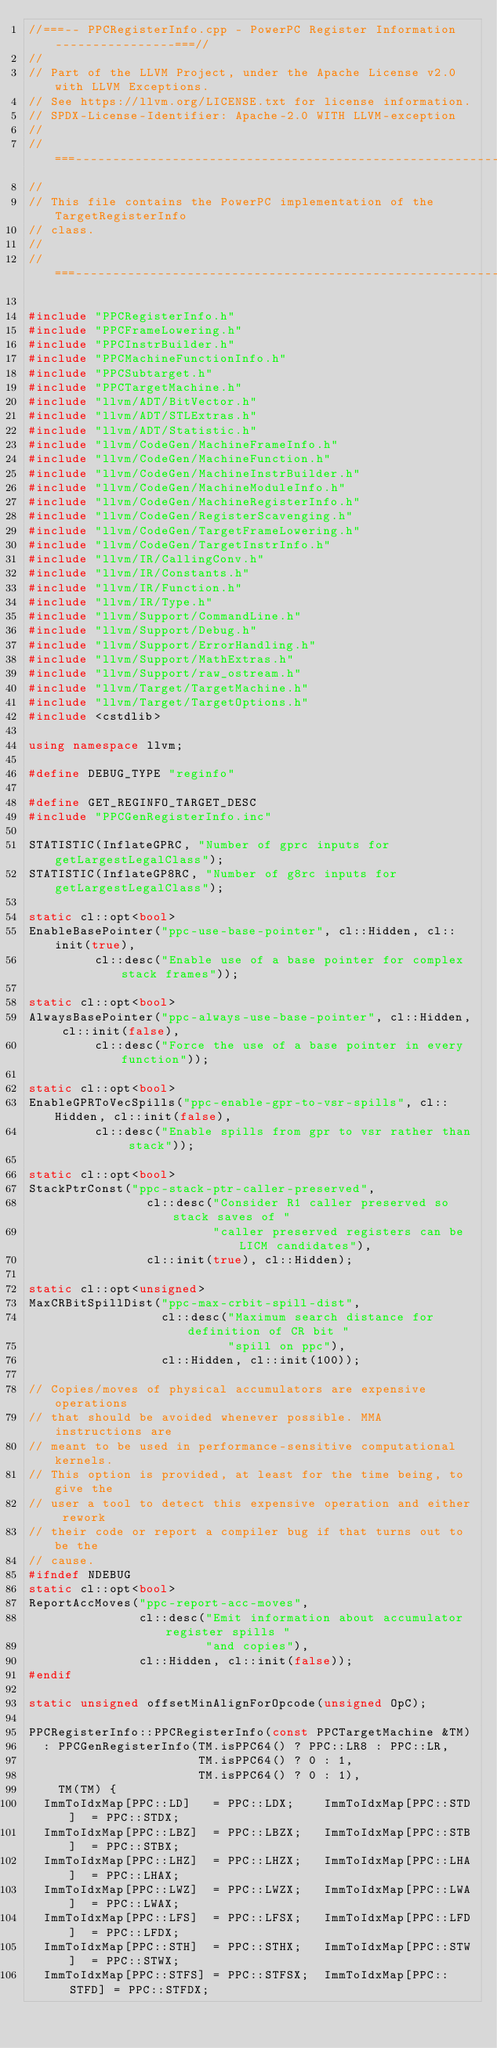<code> <loc_0><loc_0><loc_500><loc_500><_C++_>//===-- PPCRegisterInfo.cpp - PowerPC Register Information ----------------===//
//
// Part of the LLVM Project, under the Apache License v2.0 with LLVM Exceptions.
// See https://llvm.org/LICENSE.txt for license information.
// SPDX-License-Identifier: Apache-2.0 WITH LLVM-exception
//
//===----------------------------------------------------------------------===//
//
// This file contains the PowerPC implementation of the TargetRegisterInfo
// class.
//
//===----------------------------------------------------------------------===//

#include "PPCRegisterInfo.h"
#include "PPCFrameLowering.h"
#include "PPCInstrBuilder.h"
#include "PPCMachineFunctionInfo.h"
#include "PPCSubtarget.h"
#include "PPCTargetMachine.h"
#include "llvm/ADT/BitVector.h"
#include "llvm/ADT/STLExtras.h"
#include "llvm/ADT/Statistic.h"
#include "llvm/CodeGen/MachineFrameInfo.h"
#include "llvm/CodeGen/MachineFunction.h"
#include "llvm/CodeGen/MachineInstrBuilder.h"
#include "llvm/CodeGen/MachineModuleInfo.h"
#include "llvm/CodeGen/MachineRegisterInfo.h"
#include "llvm/CodeGen/RegisterScavenging.h"
#include "llvm/CodeGen/TargetFrameLowering.h"
#include "llvm/CodeGen/TargetInstrInfo.h"
#include "llvm/IR/CallingConv.h"
#include "llvm/IR/Constants.h"
#include "llvm/IR/Function.h"
#include "llvm/IR/Type.h"
#include "llvm/Support/CommandLine.h"
#include "llvm/Support/Debug.h"
#include "llvm/Support/ErrorHandling.h"
#include "llvm/Support/MathExtras.h"
#include "llvm/Support/raw_ostream.h"
#include "llvm/Target/TargetMachine.h"
#include "llvm/Target/TargetOptions.h"
#include <cstdlib>

using namespace llvm;

#define DEBUG_TYPE "reginfo"

#define GET_REGINFO_TARGET_DESC
#include "PPCGenRegisterInfo.inc"

STATISTIC(InflateGPRC, "Number of gprc inputs for getLargestLegalClass");
STATISTIC(InflateGP8RC, "Number of g8rc inputs for getLargestLegalClass");

static cl::opt<bool>
EnableBasePointer("ppc-use-base-pointer", cl::Hidden, cl::init(true),
         cl::desc("Enable use of a base pointer for complex stack frames"));

static cl::opt<bool>
AlwaysBasePointer("ppc-always-use-base-pointer", cl::Hidden, cl::init(false),
         cl::desc("Force the use of a base pointer in every function"));

static cl::opt<bool>
EnableGPRToVecSpills("ppc-enable-gpr-to-vsr-spills", cl::Hidden, cl::init(false),
         cl::desc("Enable spills from gpr to vsr rather than stack"));

static cl::opt<bool>
StackPtrConst("ppc-stack-ptr-caller-preserved",
                cl::desc("Consider R1 caller preserved so stack saves of "
                         "caller preserved registers can be LICM candidates"),
                cl::init(true), cl::Hidden);

static cl::opt<unsigned>
MaxCRBitSpillDist("ppc-max-crbit-spill-dist",
                  cl::desc("Maximum search distance for definition of CR bit "
                           "spill on ppc"),
                  cl::Hidden, cl::init(100));

// Copies/moves of physical accumulators are expensive operations
// that should be avoided whenever possible. MMA instructions are
// meant to be used in performance-sensitive computational kernels.
// This option is provided, at least for the time being, to give the
// user a tool to detect this expensive operation and either rework
// their code or report a compiler bug if that turns out to be the
// cause.
#ifndef NDEBUG
static cl::opt<bool>
ReportAccMoves("ppc-report-acc-moves",
               cl::desc("Emit information about accumulator register spills "
                        "and copies"),
               cl::Hidden, cl::init(false));
#endif

static unsigned offsetMinAlignForOpcode(unsigned OpC);

PPCRegisterInfo::PPCRegisterInfo(const PPCTargetMachine &TM)
  : PPCGenRegisterInfo(TM.isPPC64() ? PPC::LR8 : PPC::LR,
                       TM.isPPC64() ? 0 : 1,
                       TM.isPPC64() ? 0 : 1),
    TM(TM) {
  ImmToIdxMap[PPC::LD]   = PPC::LDX;    ImmToIdxMap[PPC::STD]  = PPC::STDX;
  ImmToIdxMap[PPC::LBZ]  = PPC::LBZX;   ImmToIdxMap[PPC::STB]  = PPC::STBX;
  ImmToIdxMap[PPC::LHZ]  = PPC::LHZX;   ImmToIdxMap[PPC::LHA]  = PPC::LHAX;
  ImmToIdxMap[PPC::LWZ]  = PPC::LWZX;   ImmToIdxMap[PPC::LWA]  = PPC::LWAX;
  ImmToIdxMap[PPC::LFS]  = PPC::LFSX;   ImmToIdxMap[PPC::LFD]  = PPC::LFDX;
  ImmToIdxMap[PPC::STH]  = PPC::STHX;   ImmToIdxMap[PPC::STW]  = PPC::STWX;
  ImmToIdxMap[PPC::STFS] = PPC::STFSX;  ImmToIdxMap[PPC::STFD] = PPC::STFDX;</code> 